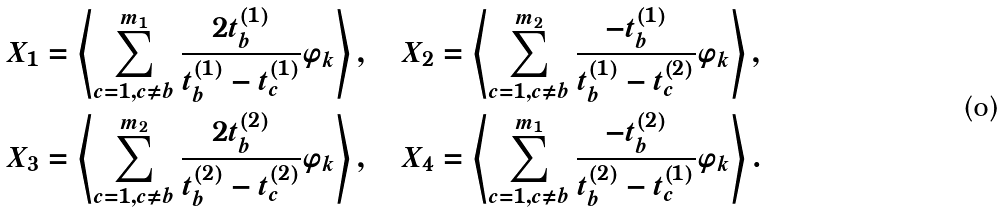<formula> <loc_0><loc_0><loc_500><loc_500>& X _ { 1 } = \left \langle \sum _ { c = 1 , c \neq b } ^ { m _ { 1 } } \frac { 2 t _ { b } ^ { ( 1 ) } } { t _ { b } ^ { ( 1 ) } - t _ { c } ^ { ( 1 ) } } \varphi _ { k } \right \rangle , \quad X _ { 2 } = \left \langle \sum _ { c = 1 , c \neq b } ^ { m _ { 2 } } \frac { - t _ { b } ^ { ( 1 ) } } { t _ { b } ^ { ( 1 ) } - t _ { c } ^ { ( 2 ) } } \varphi _ { k } \right \rangle , \\ & X _ { 3 } = \left \langle \sum _ { c = 1 , c \neq b } ^ { m _ { 2 } } \frac { 2 t _ { b } ^ { ( 2 ) } } { t _ { b } ^ { ( 2 ) } - t _ { c } ^ { ( 2 ) } } \varphi _ { k } \right \rangle , \quad X _ { 4 } = \left \langle \sum _ { c = 1 , c \neq b } ^ { m _ { 1 } } \frac { - t _ { b } ^ { ( 2 ) } } { t _ { b } ^ { ( 2 ) } - t _ { c } ^ { ( 1 ) } } \varphi _ { k } \right \rangle .</formula> 